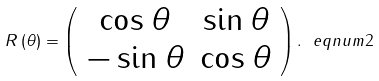Convert formula to latex. <formula><loc_0><loc_0><loc_500><loc_500>R \left ( \theta \right ) = \left ( \begin{array} { c c } \cos \theta & \sin \theta \\ - \sin \theta & \cos \theta \end{array} \right ) . \ e q n u m { 2 }</formula> 